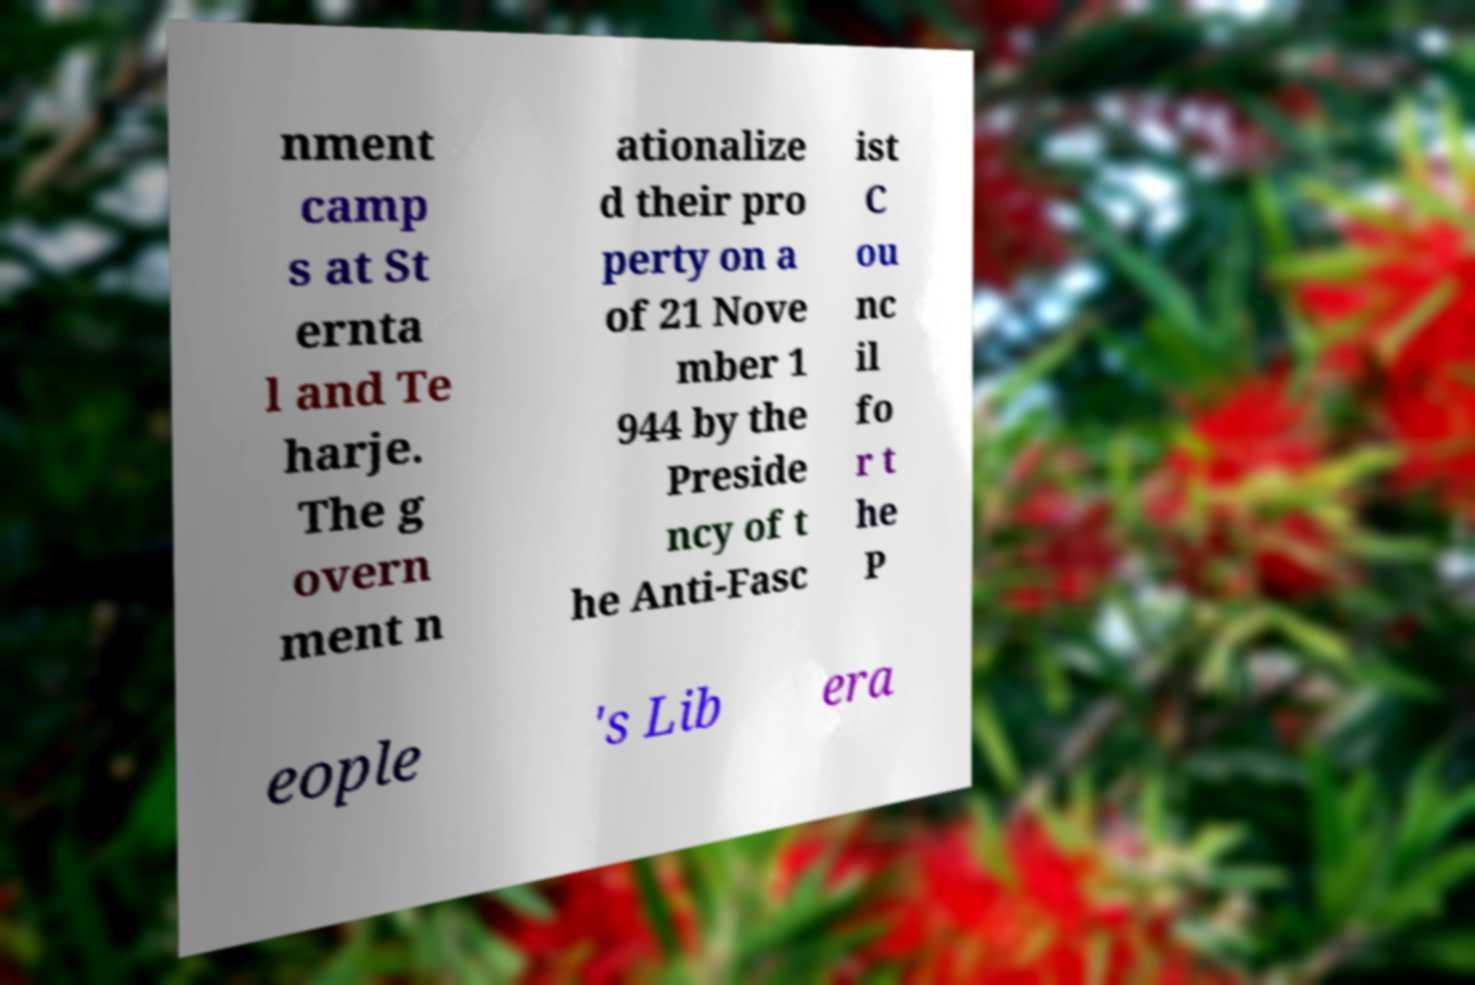Can you accurately transcribe the text from the provided image for me? nment camp s at St ernta l and Te harje. The g overn ment n ationalize d their pro perty on a of 21 Nove mber 1 944 by the Preside ncy of t he Anti-Fasc ist C ou nc il fo r t he P eople 's Lib era 